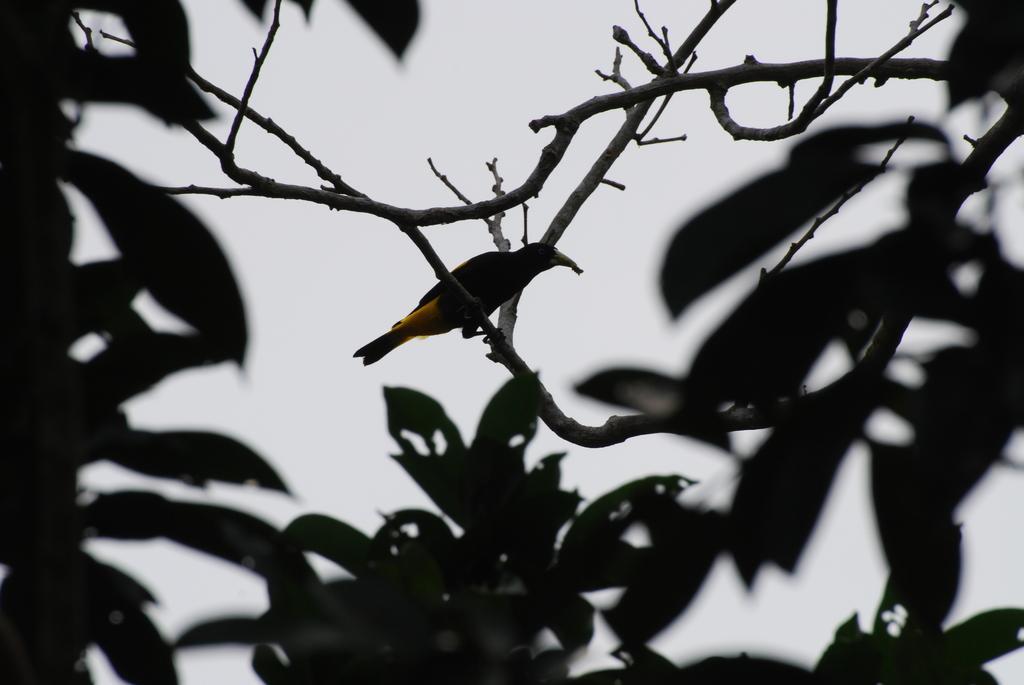How would you summarize this image in a sentence or two? In this picture we can see a bird on the branch. There are leaves. In the background there is sky. 